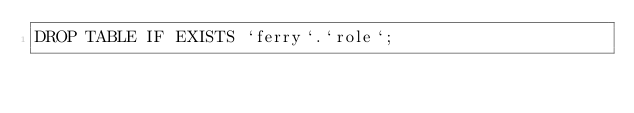<code> <loc_0><loc_0><loc_500><loc_500><_SQL_>DROP TABLE IF EXISTS `ferry`.`role`;</code> 